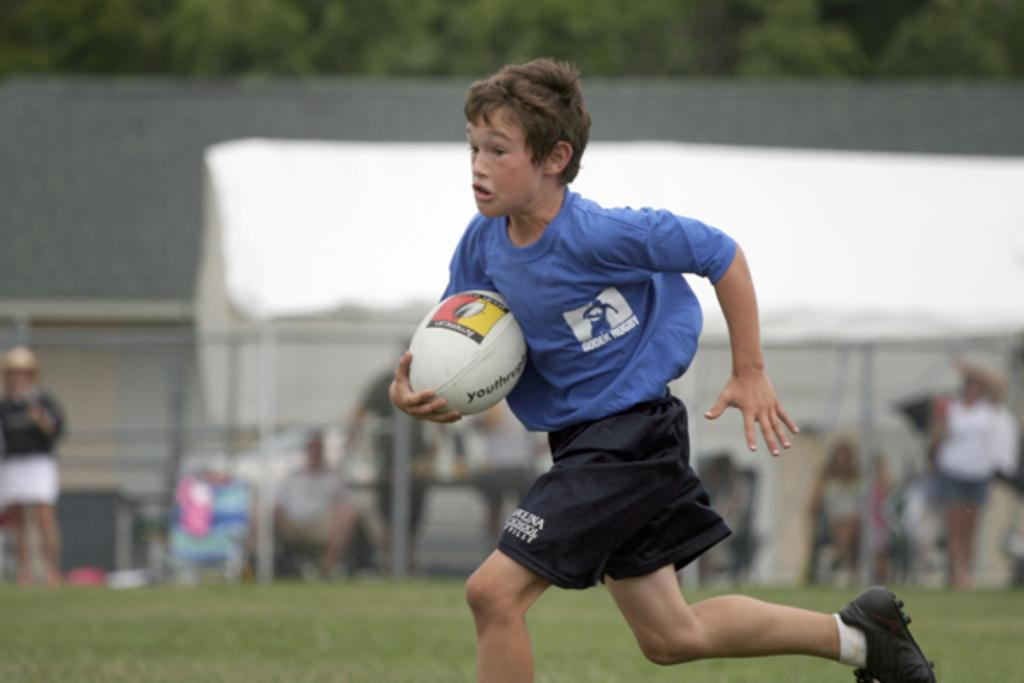Who is present in the image? There is a boy in the image. What is the boy holding in his hand? The boy is holding a ball in his hand. What is the boy doing in the image? The boy is running. Where is the boy located? The location is a football ground. What type of farm animals can be seen in the image? There are no farm animals present in the image; it features a boy running with a ball on a football ground. 